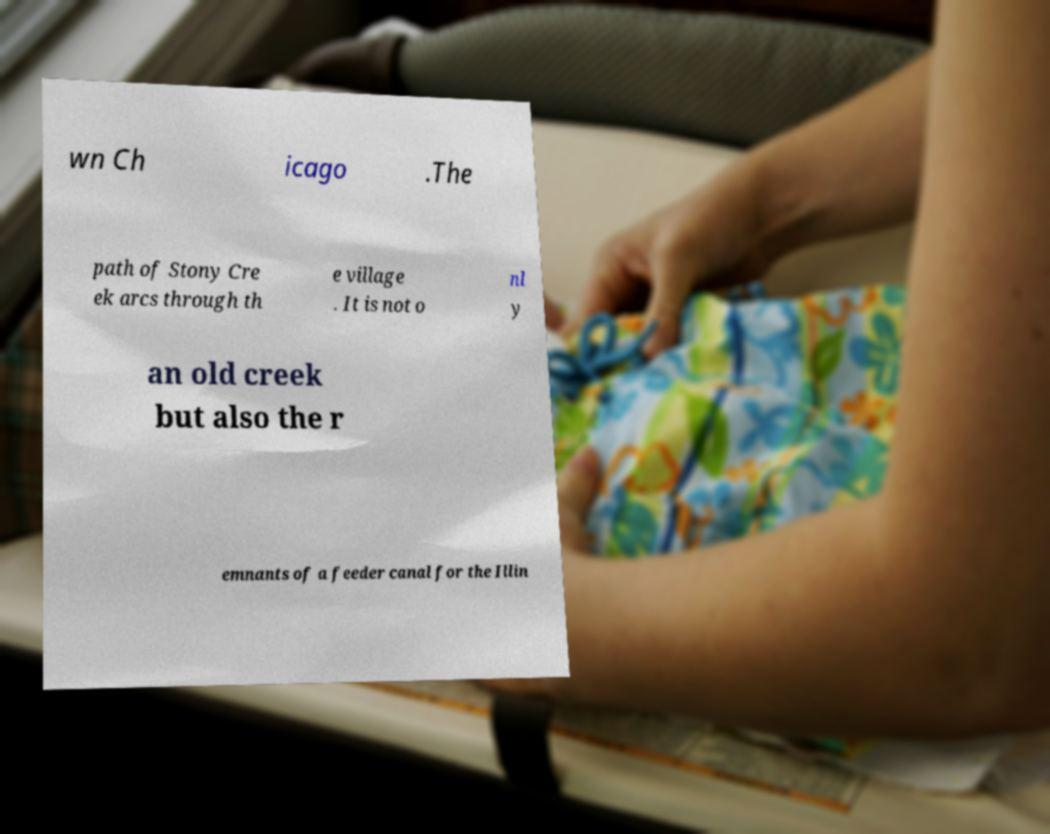Can you accurately transcribe the text from the provided image for me? wn Ch icago .The path of Stony Cre ek arcs through th e village . It is not o nl y an old creek but also the r emnants of a feeder canal for the Illin 